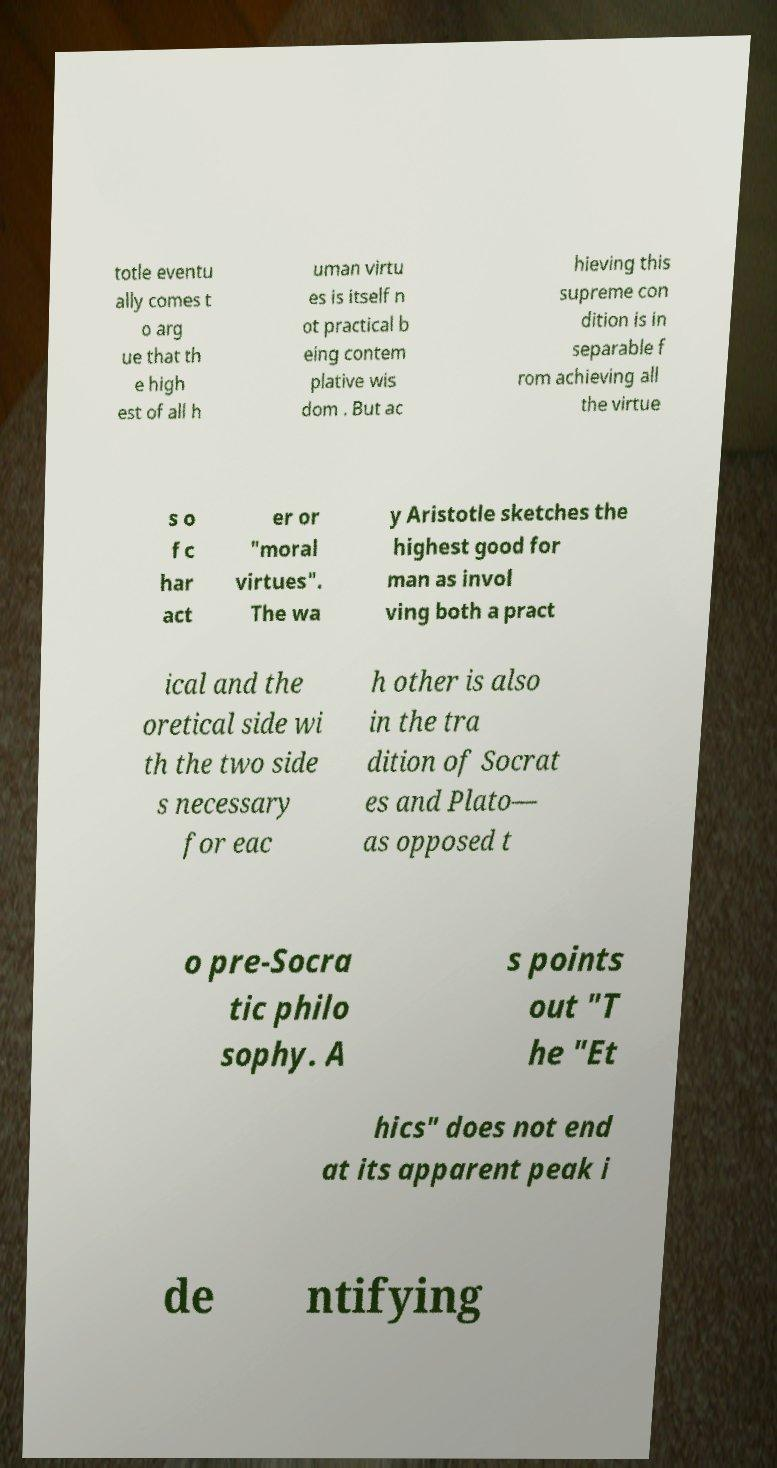Please identify and transcribe the text found in this image. totle eventu ally comes t o arg ue that th e high est of all h uman virtu es is itself n ot practical b eing contem plative wis dom . But ac hieving this supreme con dition is in separable f rom achieving all the virtue s o f c har act er or "moral virtues". The wa y Aristotle sketches the highest good for man as invol ving both a pract ical and the oretical side wi th the two side s necessary for eac h other is also in the tra dition of Socrat es and Plato— as opposed t o pre-Socra tic philo sophy. A s points out "T he "Et hics" does not end at its apparent peak i de ntifying 